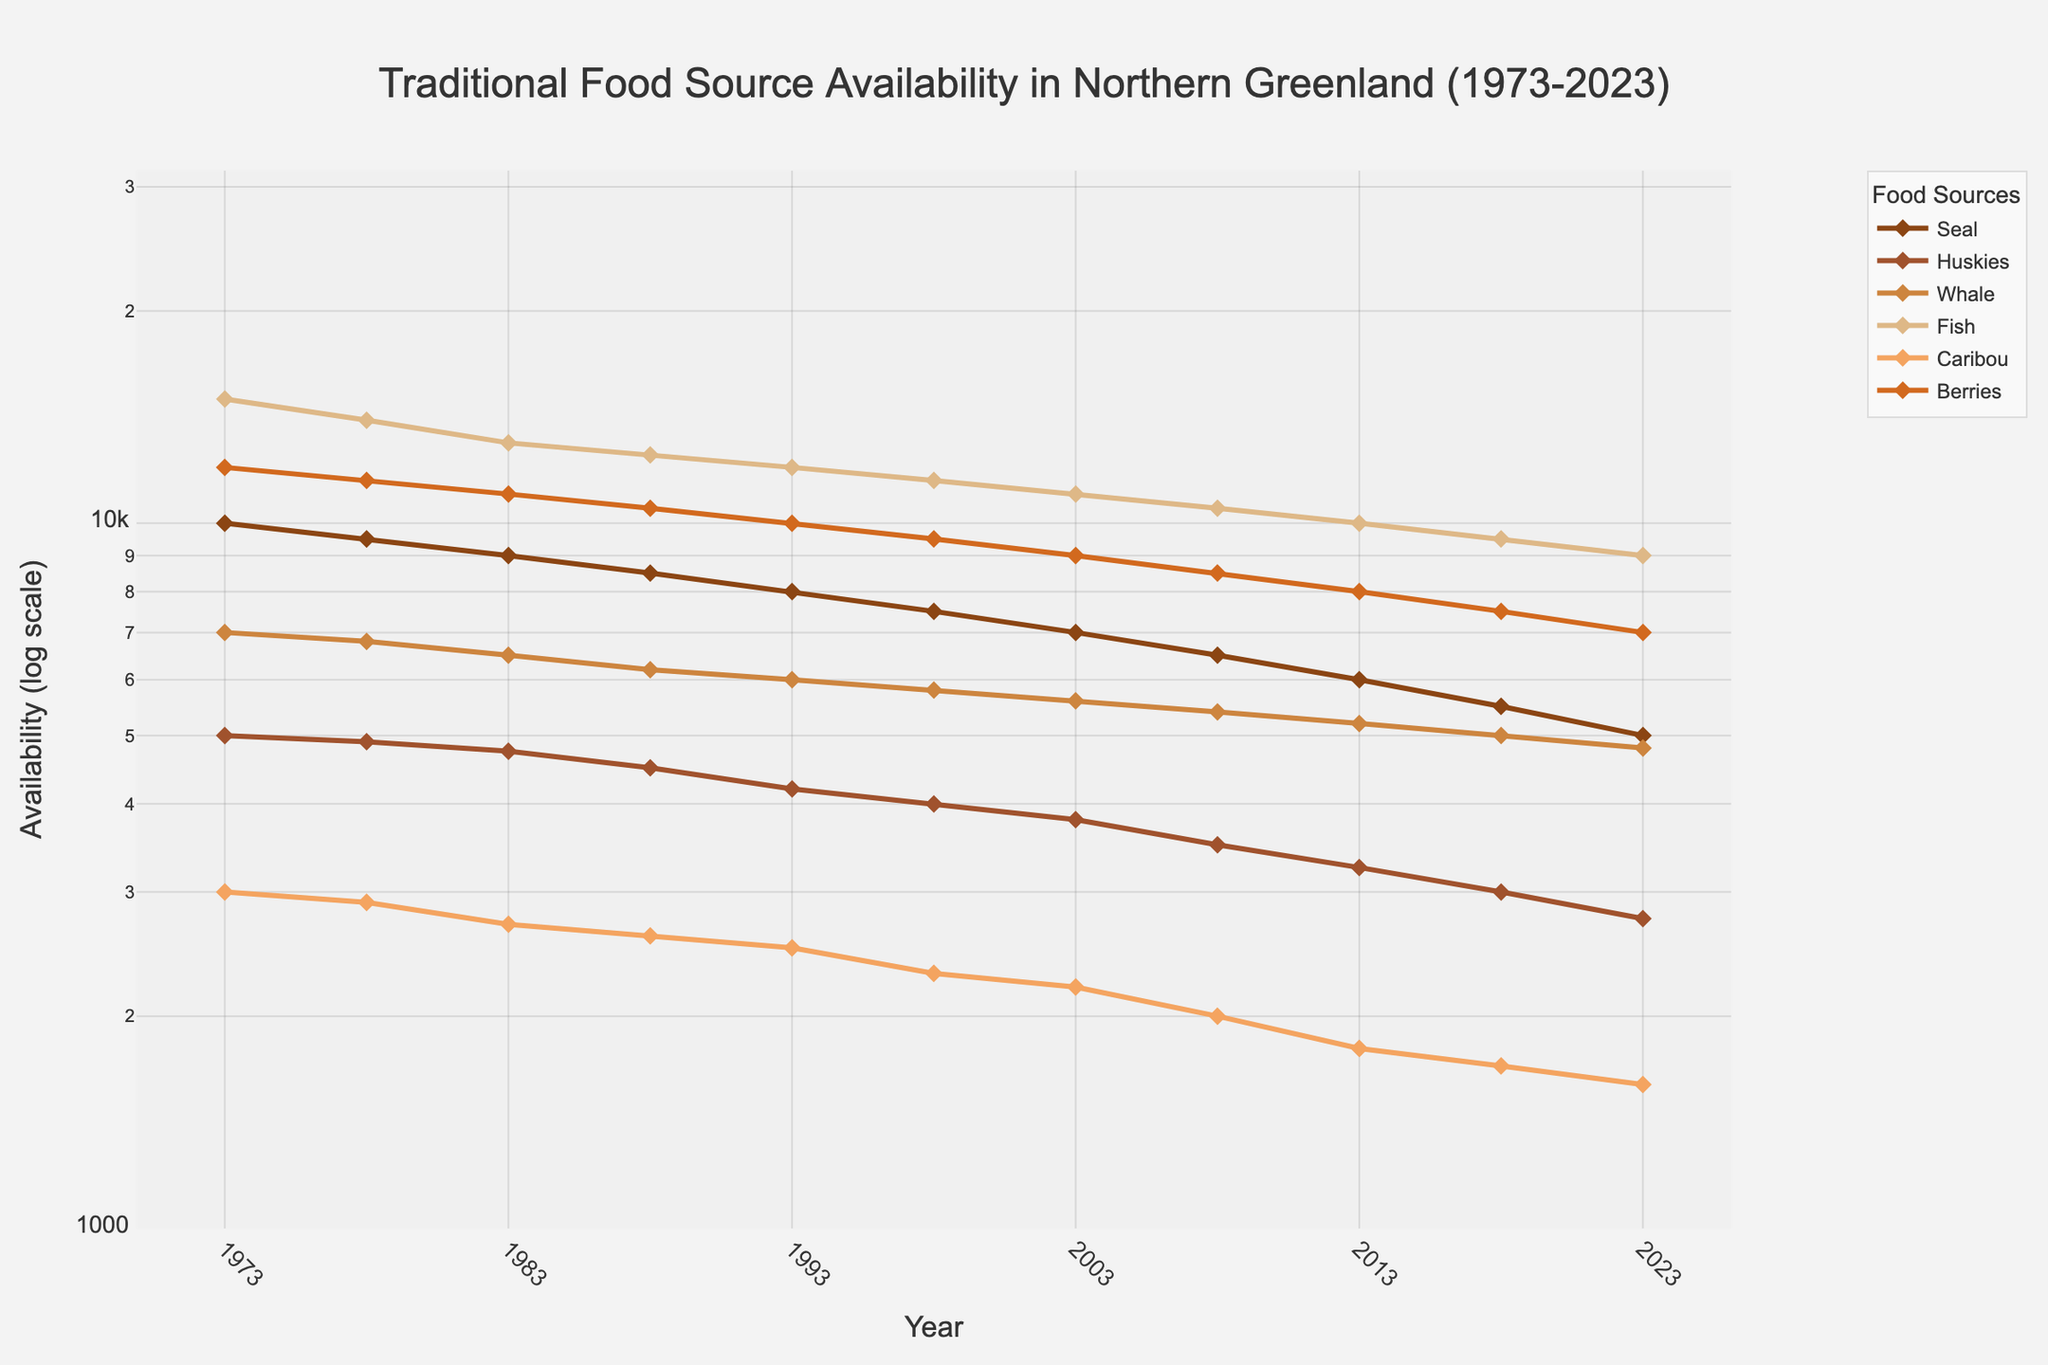What is the title of the figure? The title of the figure is prominently displayed at the top and provides an overview of the plotted data. It reads "Traditional Food Source Availability in Northern Greenland (1973-2023)."
Answer: Traditional Food Source Availability in Northern Greenland (1973-2023) Which food source had the highest availability in 1973? Looking at the plotted data for each food source in 1973, we see that Fish had the highest availability with around 15,000 units.
Answer: Fish How did the availability of Caribou change from 1973 to 2023? To find how the availability of Caribou changed, compare its values in 1973 (3,000) and 2023 (1,600). The availability decreased by 1,400 units over the 50 years.
Answer: Decreased by 1,400 Which food source shows the least decrease in availability over the 50 years? Track the decrease for each food source from 1973 to 2023 and determine which has the smallest difference. Huskies decreased from 5,000 to 2,750, the least among the sources.
Answer: Huskies Between which years did the availability of Seal decrease the most? Examine the Seal's availability at each year interval and identify the largest reduction. It decreases from 2023 (5,000) back to 2018 (5,500), showing the most significant drop of 500 units.
Answer: Between 2018 and 2023 What was the general trend for the availability of Whale from 1973 to 2023? By assessing the Whale's plotted line from 1973 (7,000) to 2023 (4,800), it is evident that the availability shows a decreasing trend over time.
Answer: Decreasing Which food source had a consistent decline in availability over the entire period? Analyze the plotted lines for all food sources. Seal, Huskies, Whale, Fish, Caribou, and Berries all reveal a consistent decline.
Answer: All Is there any year where the availability of Seal and Caribou was equal? Compare the plotted lines for Seal and Caribou year by year. Both lines do not intersect at any point, implying their availabilities were never equal.
Answer: No In what year was the availability of Berries closest to 10,000 units? Look at the availability values for Berries over the years and identify the closest to 10,000. In 1993, Berries had an availability of 10,000 units.
Answer: 1993 Which food source shows the steepest decline in availability on the log scale? Observe the steepness of the plotted lines for every food source. Fish shows the most considerable decline from 15,000 in 1973 to 9,000 in 2023, evident on a log scale.
Answer: Fish 